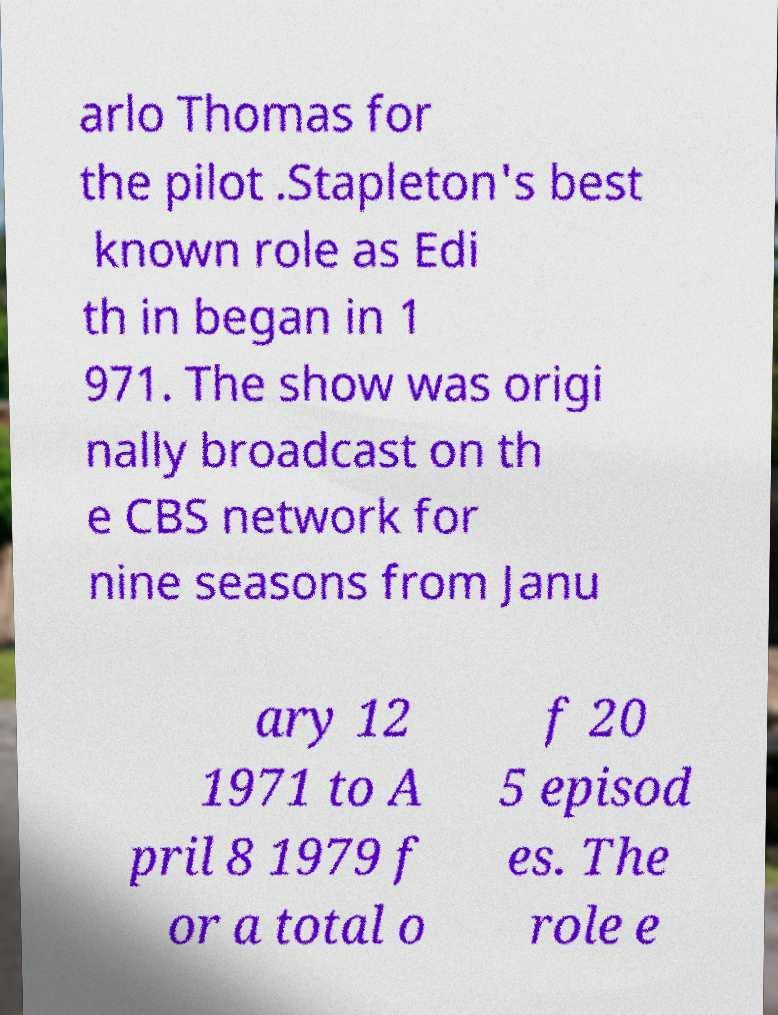Please read and relay the text visible in this image. What does it say? arlo Thomas for the pilot .Stapleton's best known role as Edi th in began in 1 971. The show was origi nally broadcast on th e CBS network for nine seasons from Janu ary 12 1971 to A pril 8 1979 f or a total o f 20 5 episod es. The role e 